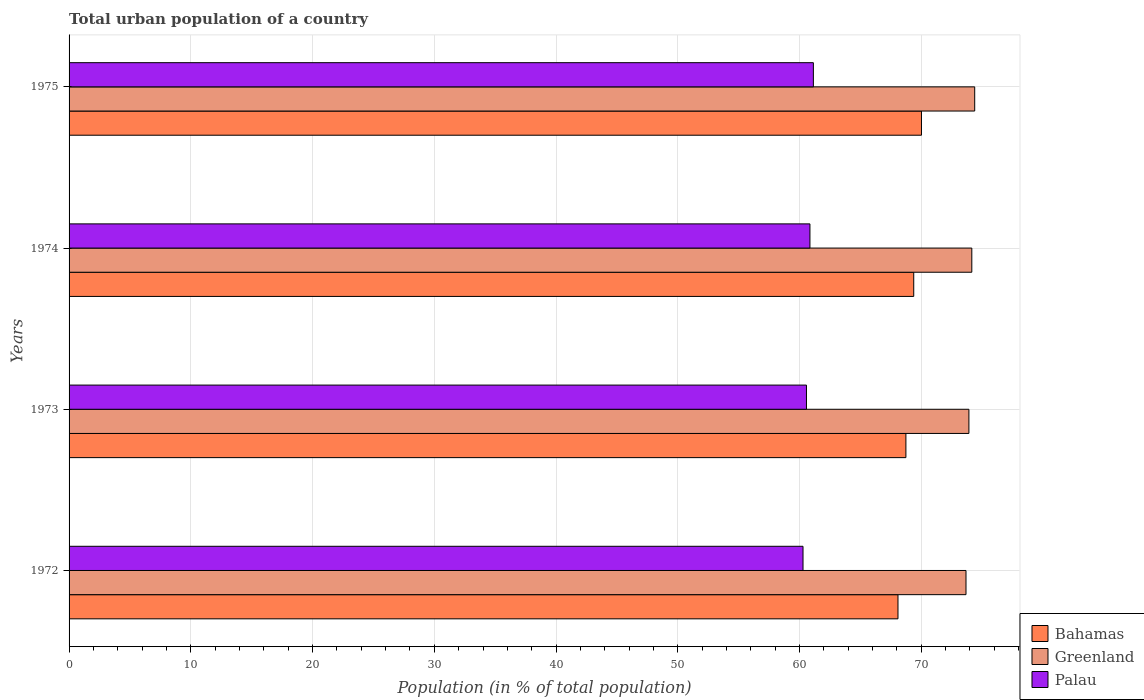How many different coloured bars are there?
Keep it short and to the point. 3. How many groups of bars are there?
Ensure brevity in your answer.  4. Are the number of bars on each tick of the Y-axis equal?
Provide a succinct answer. Yes. How many bars are there on the 2nd tick from the top?
Provide a succinct answer. 3. How many bars are there on the 4th tick from the bottom?
Offer a very short reply. 3. What is the label of the 1st group of bars from the top?
Your response must be concise. 1975. What is the urban population in Greenland in 1974?
Make the answer very short. 74.15. Across all years, what is the maximum urban population in Palau?
Your answer should be very brief. 61.14. Across all years, what is the minimum urban population in Bahamas?
Provide a succinct answer. 68.09. In which year was the urban population in Bahamas maximum?
Offer a very short reply. 1975. What is the total urban population in Bahamas in the graph?
Ensure brevity in your answer.  276.22. What is the difference between the urban population in Greenland in 1974 and that in 1975?
Your response must be concise. -0.24. What is the difference between the urban population in Bahamas in 1975 and the urban population in Greenland in 1972?
Your response must be concise. -3.66. What is the average urban population in Greenland per year?
Give a very brief answer. 74.03. In the year 1974, what is the difference between the urban population in Palau and urban population in Greenland?
Make the answer very short. -13.3. In how many years, is the urban population in Bahamas greater than 70 %?
Your response must be concise. 1. What is the ratio of the urban population in Greenland in 1972 to that in 1973?
Keep it short and to the point. 1. Is the urban population in Greenland in 1972 less than that in 1974?
Your answer should be compact. Yes. What is the difference between the highest and the second highest urban population in Bahamas?
Offer a terse response. 0.64. What is the difference between the highest and the lowest urban population in Greenland?
Provide a succinct answer. 0.71. In how many years, is the urban population in Greenland greater than the average urban population in Greenland taken over all years?
Make the answer very short. 2. What does the 2nd bar from the top in 1972 represents?
Provide a succinct answer. Greenland. What does the 1st bar from the bottom in 1974 represents?
Give a very brief answer. Bahamas. How many bars are there?
Provide a short and direct response. 12. Are the values on the major ticks of X-axis written in scientific E-notation?
Provide a short and direct response. No. Does the graph contain any zero values?
Give a very brief answer. No. Where does the legend appear in the graph?
Give a very brief answer. Bottom right. How many legend labels are there?
Offer a terse response. 3. How are the legend labels stacked?
Provide a short and direct response. Vertical. What is the title of the graph?
Your answer should be compact. Total urban population of a country. What is the label or title of the X-axis?
Ensure brevity in your answer.  Population (in % of total population). What is the label or title of the Y-axis?
Offer a terse response. Years. What is the Population (in % of total population) in Bahamas in 1972?
Offer a very short reply. 68.09. What is the Population (in % of total population) of Greenland in 1972?
Your answer should be very brief. 73.67. What is the Population (in % of total population) in Palau in 1972?
Your answer should be compact. 60.29. What is the Population (in % of total population) in Bahamas in 1973?
Your response must be concise. 68.74. What is the Population (in % of total population) in Greenland in 1973?
Give a very brief answer. 73.91. What is the Population (in % of total population) of Palau in 1973?
Give a very brief answer. 60.57. What is the Population (in % of total population) of Bahamas in 1974?
Make the answer very short. 69.38. What is the Population (in % of total population) of Greenland in 1974?
Provide a short and direct response. 74.15. What is the Population (in % of total population) in Palau in 1974?
Give a very brief answer. 60.85. What is the Population (in % of total population) of Bahamas in 1975?
Keep it short and to the point. 70.02. What is the Population (in % of total population) in Greenland in 1975?
Keep it short and to the point. 74.39. What is the Population (in % of total population) in Palau in 1975?
Your response must be concise. 61.14. Across all years, what is the maximum Population (in % of total population) of Bahamas?
Your response must be concise. 70.02. Across all years, what is the maximum Population (in % of total population) in Greenland?
Your answer should be very brief. 74.39. Across all years, what is the maximum Population (in % of total population) of Palau?
Ensure brevity in your answer.  61.14. Across all years, what is the minimum Population (in % of total population) in Bahamas?
Give a very brief answer. 68.09. Across all years, what is the minimum Population (in % of total population) in Greenland?
Offer a very short reply. 73.67. Across all years, what is the minimum Population (in % of total population) of Palau?
Your answer should be compact. 60.29. What is the total Population (in % of total population) in Bahamas in the graph?
Keep it short and to the point. 276.22. What is the total Population (in % of total population) in Greenland in the graph?
Keep it short and to the point. 296.13. What is the total Population (in % of total population) of Palau in the graph?
Your answer should be very brief. 242.85. What is the difference between the Population (in % of total population) in Bahamas in 1972 and that in 1973?
Your answer should be very brief. -0.65. What is the difference between the Population (in % of total population) in Greenland in 1972 and that in 1973?
Offer a terse response. -0.24. What is the difference between the Population (in % of total population) in Palau in 1972 and that in 1973?
Provide a succinct answer. -0.28. What is the difference between the Population (in % of total population) of Bahamas in 1972 and that in 1974?
Keep it short and to the point. -1.29. What is the difference between the Population (in % of total population) of Greenland in 1972 and that in 1974?
Your answer should be compact. -0.48. What is the difference between the Population (in % of total population) of Palau in 1972 and that in 1974?
Keep it short and to the point. -0.57. What is the difference between the Population (in % of total population) of Bahamas in 1972 and that in 1975?
Offer a very short reply. -1.93. What is the difference between the Population (in % of total population) of Greenland in 1972 and that in 1975?
Offer a terse response. -0.71. What is the difference between the Population (in % of total population) of Palau in 1972 and that in 1975?
Make the answer very short. -0.85. What is the difference between the Population (in % of total population) in Bahamas in 1973 and that in 1974?
Keep it short and to the point. -0.64. What is the difference between the Population (in % of total population) of Greenland in 1973 and that in 1974?
Your answer should be compact. -0.24. What is the difference between the Population (in % of total population) of Palau in 1973 and that in 1974?
Make the answer very short. -0.28. What is the difference between the Population (in % of total population) in Bahamas in 1973 and that in 1975?
Offer a terse response. -1.28. What is the difference between the Population (in % of total population) in Greenland in 1973 and that in 1975?
Your answer should be very brief. -0.47. What is the difference between the Population (in % of total population) of Palau in 1973 and that in 1975?
Your response must be concise. -0.57. What is the difference between the Population (in % of total population) in Bahamas in 1974 and that in 1975?
Your response must be concise. -0.64. What is the difference between the Population (in % of total population) of Greenland in 1974 and that in 1975?
Keep it short and to the point. -0.24. What is the difference between the Population (in % of total population) of Palau in 1974 and that in 1975?
Offer a very short reply. -0.28. What is the difference between the Population (in % of total population) of Bahamas in 1972 and the Population (in % of total population) of Greenland in 1973?
Make the answer very short. -5.83. What is the difference between the Population (in % of total population) of Bahamas in 1972 and the Population (in % of total population) of Palau in 1973?
Give a very brief answer. 7.52. What is the difference between the Population (in % of total population) of Greenland in 1972 and the Population (in % of total population) of Palau in 1973?
Your answer should be very brief. 13.1. What is the difference between the Population (in % of total population) in Bahamas in 1972 and the Population (in % of total population) in Greenland in 1974?
Your answer should be very brief. -6.06. What is the difference between the Population (in % of total population) of Bahamas in 1972 and the Population (in % of total population) of Palau in 1974?
Give a very brief answer. 7.23. What is the difference between the Population (in % of total population) of Greenland in 1972 and the Population (in % of total population) of Palau in 1974?
Keep it short and to the point. 12.82. What is the difference between the Population (in % of total population) in Bahamas in 1972 and the Population (in % of total population) in Greenland in 1975?
Keep it short and to the point. -6.3. What is the difference between the Population (in % of total population) of Bahamas in 1972 and the Population (in % of total population) of Palau in 1975?
Your response must be concise. 6.95. What is the difference between the Population (in % of total population) in Greenland in 1972 and the Population (in % of total population) in Palau in 1975?
Provide a succinct answer. 12.54. What is the difference between the Population (in % of total population) of Bahamas in 1973 and the Population (in % of total population) of Greenland in 1974?
Offer a terse response. -5.41. What is the difference between the Population (in % of total population) of Bahamas in 1973 and the Population (in % of total population) of Palau in 1974?
Your answer should be compact. 7.88. What is the difference between the Population (in % of total population) of Greenland in 1973 and the Population (in % of total population) of Palau in 1974?
Make the answer very short. 13.06. What is the difference between the Population (in % of total population) in Bahamas in 1973 and the Population (in % of total population) in Greenland in 1975?
Give a very brief answer. -5.65. What is the difference between the Population (in % of total population) of Greenland in 1973 and the Population (in % of total population) of Palau in 1975?
Ensure brevity in your answer.  12.78. What is the difference between the Population (in % of total population) in Bahamas in 1974 and the Population (in % of total population) in Greenland in 1975?
Keep it short and to the point. -5.01. What is the difference between the Population (in % of total population) in Bahamas in 1974 and the Population (in % of total population) in Palau in 1975?
Keep it short and to the point. 8.24. What is the difference between the Population (in % of total population) of Greenland in 1974 and the Population (in % of total population) of Palau in 1975?
Provide a succinct answer. 13.01. What is the average Population (in % of total population) in Bahamas per year?
Keep it short and to the point. 69.06. What is the average Population (in % of total population) of Greenland per year?
Make the answer very short. 74.03. What is the average Population (in % of total population) in Palau per year?
Ensure brevity in your answer.  60.71. In the year 1972, what is the difference between the Population (in % of total population) in Bahamas and Population (in % of total population) in Greenland?
Provide a succinct answer. -5.59. In the year 1972, what is the difference between the Population (in % of total population) of Bahamas and Population (in % of total population) of Palau?
Provide a short and direct response. 7.8. In the year 1972, what is the difference between the Population (in % of total population) of Greenland and Population (in % of total population) of Palau?
Provide a short and direct response. 13.39. In the year 1973, what is the difference between the Population (in % of total population) of Bahamas and Population (in % of total population) of Greenland?
Your answer should be compact. -5.18. In the year 1973, what is the difference between the Population (in % of total population) in Bahamas and Population (in % of total population) in Palau?
Offer a terse response. 8.17. In the year 1973, what is the difference between the Population (in % of total population) in Greenland and Population (in % of total population) in Palau?
Give a very brief answer. 13.34. In the year 1974, what is the difference between the Population (in % of total population) of Bahamas and Population (in % of total population) of Greenland?
Offer a very short reply. -4.77. In the year 1974, what is the difference between the Population (in % of total population) in Bahamas and Population (in % of total population) in Palau?
Your answer should be compact. 8.53. In the year 1974, what is the difference between the Population (in % of total population) in Greenland and Population (in % of total population) in Palau?
Offer a terse response. 13.3. In the year 1975, what is the difference between the Population (in % of total population) in Bahamas and Population (in % of total population) in Greenland?
Offer a terse response. -4.37. In the year 1975, what is the difference between the Population (in % of total population) of Bahamas and Population (in % of total population) of Palau?
Your answer should be compact. 8.88. In the year 1975, what is the difference between the Population (in % of total population) of Greenland and Population (in % of total population) of Palau?
Offer a very short reply. 13.25. What is the ratio of the Population (in % of total population) in Greenland in 1972 to that in 1973?
Your answer should be compact. 1. What is the ratio of the Population (in % of total population) in Palau in 1972 to that in 1973?
Offer a terse response. 1. What is the ratio of the Population (in % of total population) of Bahamas in 1972 to that in 1974?
Keep it short and to the point. 0.98. What is the ratio of the Population (in % of total population) of Greenland in 1972 to that in 1974?
Offer a very short reply. 0.99. What is the ratio of the Population (in % of total population) of Bahamas in 1972 to that in 1975?
Keep it short and to the point. 0.97. What is the ratio of the Population (in % of total population) of Palau in 1972 to that in 1975?
Your answer should be very brief. 0.99. What is the ratio of the Population (in % of total population) of Greenland in 1973 to that in 1974?
Your response must be concise. 1. What is the ratio of the Population (in % of total population) in Palau in 1973 to that in 1974?
Your response must be concise. 1. What is the ratio of the Population (in % of total population) of Bahamas in 1973 to that in 1975?
Provide a succinct answer. 0.98. What is the ratio of the Population (in % of total population) in Greenland in 1973 to that in 1975?
Keep it short and to the point. 0.99. What is the ratio of the Population (in % of total population) in Palau in 1973 to that in 1975?
Provide a succinct answer. 0.99. What is the ratio of the Population (in % of total population) in Bahamas in 1974 to that in 1975?
Offer a terse response. 0.99. What is the ratio of the Population (in % of total population) in Greenland in 1974 to that in 1975?
Keep it short and to the point. 1. What is the ratio of the Population (in % of total population) of Palau in 1974 to that in 1975?
Keep it short and to the point. 1. What is the difference between the highest and the second highest Population (in % of total population) of Bahamas?
Ensure brevity in your answer.  0.64. What is the difference between the highest and the second highest Population (in % of total population) of Greenland?
Offer a very short reply. 0.24. What is the difference between the highest and the second highest Population (in % of total population) of Palau?
Offer a terse response. 0.28. What is the difference between the highest and the lowest Population (in % of total population) in Bahamas?
Ensure brevity in your answer.  1.93. What is the difference between the highest and the lowest Population (in % of total population) in Greenland?
Offer a very short reply. 0.71. What is the difference between the highest and the lowest Population (in % of total population) in Palau?
Offer a terse response. 0.85. 